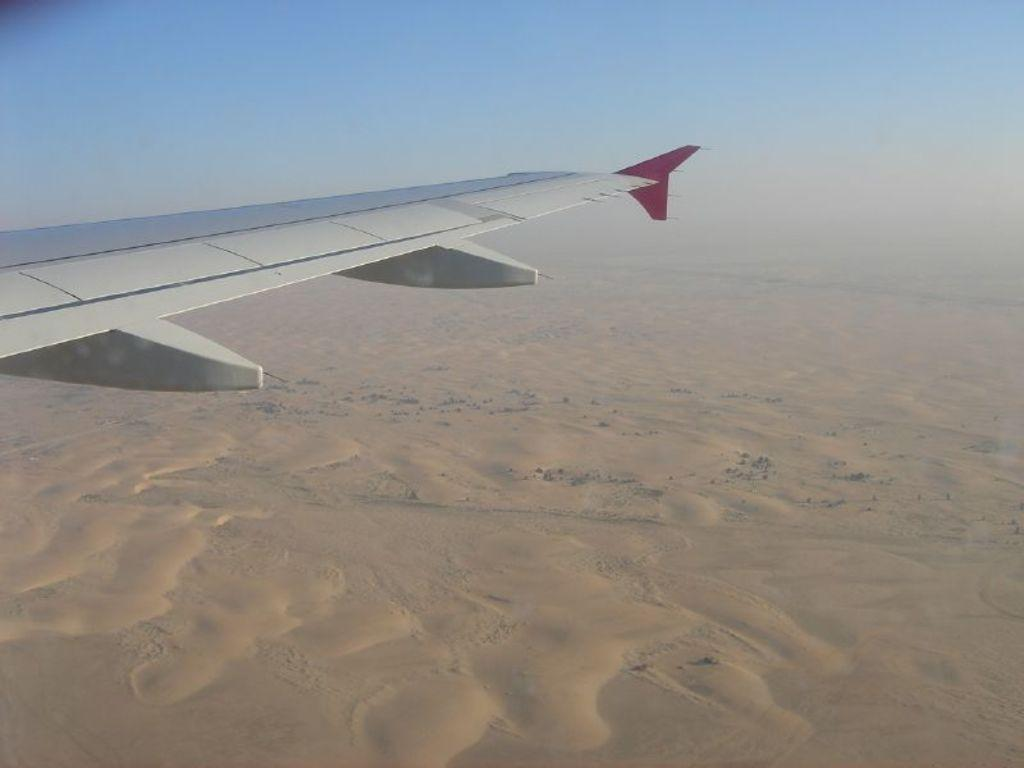What part of an airplane is visible in the image? There is a side wing of an airplane in the image. What type of terrain is depicted in the image? There is sand on the ground in the image. What is the condition of the sky in the image? The sky is clear in the image. Can you see a shoe buried in the sand in the image? There is no shoe visible in the image; it only shows a side wing of an airplane and sand on the ground. 